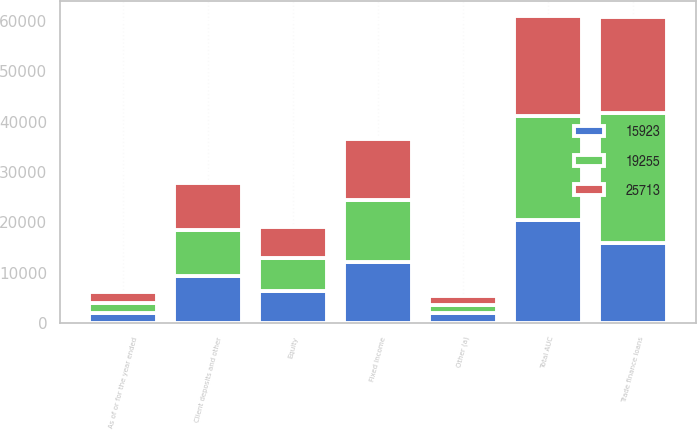Convert chart. <chart><loc_0><loc_0><loc_500><loc_500><stacked_bar_chart><ecel><fcel>As of or for the year ended<fcel>Fixed Income<fcel>Equity<fcel>Other (a)<fcel>Total AUC<fcel>Client deposits and other<fcel>Trade finance loans<nl><fcel>15923<fcel>2016<fcel>12166<fcel>6428<fcel>1926<fcel>20520<fcel>9283<fcel>15923<nl><fcel>25713<fcel>2015<fcel>12042<fcel>6194<fcel>1707<fcel>19943<fcel>9283<fcel>19255<nl><fcel>19255<fcel>2014<fcel>12328<fcel>6524<fcel>1697<fcel>20549<fcel>9283<fcel>25713<nl></chart> 